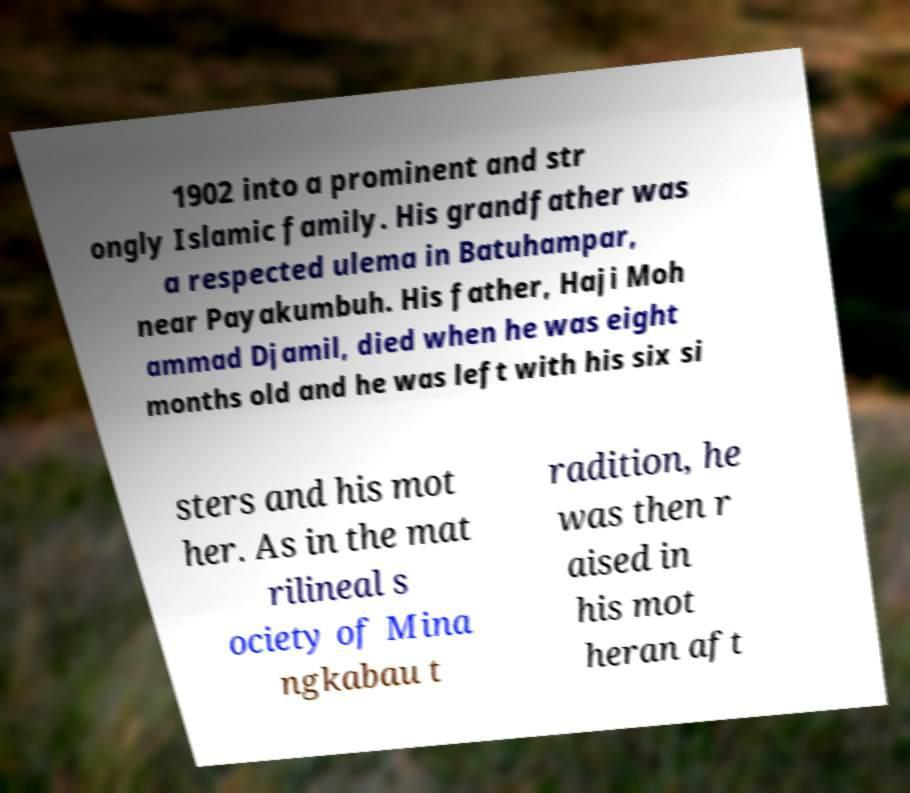Could you extract and type out the text from this image? 1902 into a prominent and str ongly Islamic family. His grandfather was a respected ulema in Batuhampar, near Payakumbuh. His father, Haji Moh ammad Djamil, died when he was eight months old and he was left with his six si sters and his mot her. As in the mat rilineal s ociety of Mina ngkabau t radition, he was then r aised in his mot heran aft 